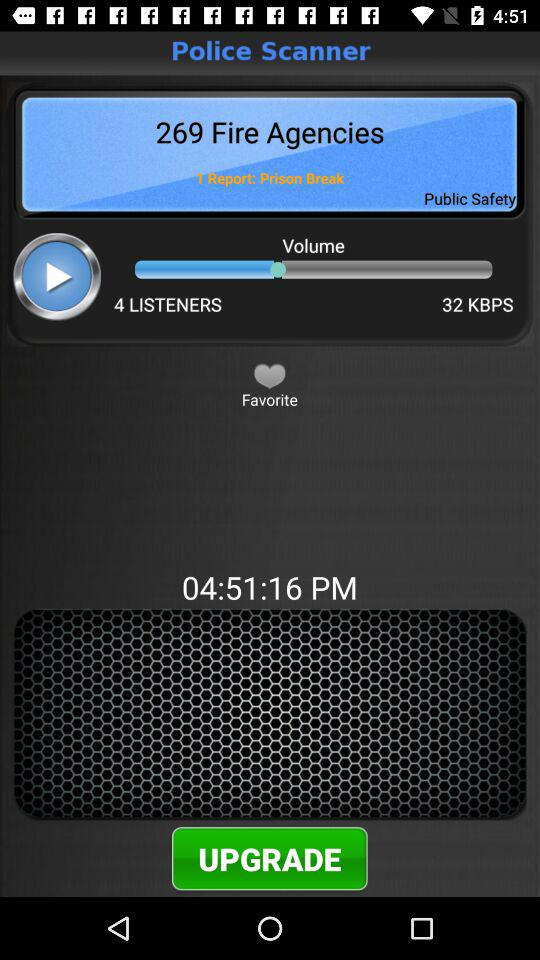How many fire agencies are there? There are 269 fire agencies. 